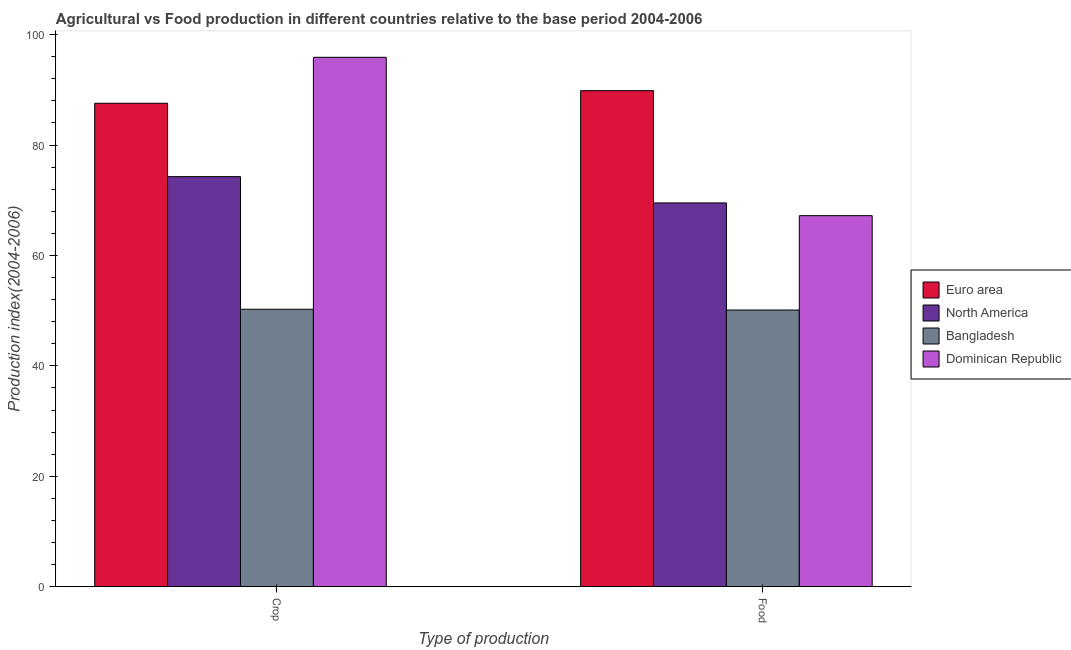How many different coloured bars are there?
Make the answer very short. 4. How many groups of bars are there?
Provide a short and direct response. 2. Are the number of bars per tick equal to the number of legend labels?
Give a very brief answer. Yes. What is the label of the 2nd group of bars from the left?
Offer a very short reply. Food. What is the crop production index in Bangladesh?
Offer a very short reply. 50.26. Across all countries, what is the maximum food production index?
Your response must be concise. 89.85. Across all countries, what is the minimum food production index?
Ensure brevity in your answer.  50.12. In which country was the crop production index maximum?
Provide a short and direct response. Dominican Republic. In which country was the food production index minimum?
Your answer should be very brief. Bangladesh. What is the total food production index in the graph?
Provide a succinct answer. 276.69. What is the difference between the food production index in Bangladesh and that in Dominican Republic?
Give a very brief answer. -17.09. What is the difference between the crop production index in Dominican Republic and the food production index in North America?
Your response must be concise. 26.37. What is the average crop production index per country?
Keep it short and to the point. 77. What is the difference between the food production index and crop production index in Bangladesh?
Offer a terse response. -0.14. What is the ratio of the crop production index in Dominican Republic to that in Euro area?
Provide a succinct answer. 1.1. What does the 1st bar from the right in Food represents?
Provide a short and direct response. Dominican Republic. How many bars are there?
Provide a succinct answer. 8. Are all the bars in the graph horizontal?
Ensure brevity in your answer.  No. What is the title of the graph?
Your answer should be very brief. Agricultural vs Food production in different countries relative to the base period 2004-2006. What is the label or title of the X-axis?
Your answer should be very brief. Type of production. What is the label or title of the Y-axis?
Offer a very short reply. Production index(2004-2006). What is the Production index(2004-2006) of Euro area in Crop?
Give a very brief answer. 87.57. What is the Production index(2004-2006) in North America in Crop?
Provide a succinct answer. 74.28. What is the Production index(2004-2006) in Bangladesh in Crop?
Your answer should be very brief. 50.26. What is the Production index(2004-2006) in Dominican Republic in Crop?
Your response must be concise. 95.89. What is the Production index(2004-2006) in Euro area in Food?
Give a very brief answer. 89.85. What is the Production index(2004-2006) of North America in Food?
Offer a very short reply. 69.52. What is the Production index(2004-2006) in Bangladesh in Food?
Your response must be concise. 50.12. What is the Production index(2004-2006) of Dominican Republic in Food?
Keep it short and to the point. 67.21. Across all Type of production, what is the maximum Production index(2004-2006) in Euro area?
Offer a very short reply. 89.85. Across all Type of production, what is the maximum Production index(2004-2006) of North America?
Offer a terse response. 74.28. Across all Type of production, what is the maximum Production index(2004-2006) in Bangladesh?
Your answer should be very brief. 50.26. Across all Type of production, what is the maximum Production index(2004-2006) of Dominican Republic?
Offer a very short reply. 95.89. Across all Type of production, what is the minimum Production index(2004-2006) in Euro area?
Keep it short and to the point. 87.57. Across all Type of production, what is the minimum Production index(2004-2006) of North America?
Offer a terse response. 69.52. Across all Type of production, what is the minimum Production index(2004-2006) in Bangladesh?
Make the answer very short. 50.12. Across all Type of production, what is the minimum Production index(2004-2006) in Dominican Republic?
Offer a terse response. 67.21. What is the total Production index(2004-2006) of Euro area in the graph?
Provide a short and direct response. 177.41. What is the total Production index(2004-2006) of North America in the graph?
Your answer should be compact. 143.8. What is the total Production index(2004-2006) of Bangladesh in the graph?
Keep it short and to the point. 100.38. What is the total Production index(2004-2006) of Dominican Republic in the graph?
Ensure brevity in your answer.  163.1. What is the difference between the Production index(2004-2006) in Euro area in Crop and that in Food?
Provide a succinct answer. -2.28. What is the difference between the Production index(2004-2006) in North America in Crop and that in Food?
Your answer should be very brief. 4.77. What is the difference between the Production index(2004-2006) of Bangladesh in Crop and that in Food?
Provide a succinct answer. 0.14. What is the difference between the Production index(2004-2006) of Dominican Republic in Crop and that in Food?
Your answer should be compact. 28.68. What is the difference between the Production index(2004-2006) of Euro area in Crop and the Production index(2004-2006) of North America in Food?
Your answer should be very brief. 18.05. What is the difference between the Production index(2004-2006) of Euro area in Crop and the Production index(2004-2006) of Bangladesh in Food?
Offer a very short reply. 37.45. What is the difference between the Production index(2004-2006) in Euro area in Crop and the Production index(2004-2006) in Dominican Republic in Food?
Your answer should be compact. 20.36. What is the difference between the Production index(2004-2006) of North America in Crop and the Production index(2004-2006) of Bangladesh in Food?
Ensure brevity in your answer.  24.16. What is the difference between the Production index(2004-2006) of North America in Crop and the Production index(2004-2006) of Dominican Republic in Food?
Your answer should be very brief. 7.07. What is the difference between the Production index(2004-2006) of Bangladesh in Crop and the Production index(2004-2006) of Dominican Republic in Food?
Your response must be concise. -16.95. What is the average Production index(2004-2006) of Euro area per Type of production?
Your answer should be compact. 88.71. What is the average Production index(2004-2006) of North America per Type of production?
Make the answer very short. 71.9. What is the average Production index(2004-2006) of Bangladesh per Type of production?
Keep it short and to the point. 50.19. What is the average Production index(2004-2006) of Dominican Republic per Type of production?
Ensure brevity in your answer.  81.55. What is the difference between the Production index(2004-2006) of Euro area and Production index(2004-2006) of North America in Crop?
Provide a short and direct response. 13.28. What is the difference between the Production index(2004-2006) in Euro area and Production index(2004-2006) in Bangladesh in Crop?
Give a very brief answer. 37.31. What is the difference between the Production index(2004-2006) of Euro area and Production index(2004-2006) of Dominican Republic in Crop?
Your answer should be compact. -8.32. What is the difference between the Production index(2004-2006) in North America and Production index(2004-2006) in Bangladesh in Crop?
Make the answer very short. 24.02. What is the difference between the Production index(2004-2006) in North America and Production index(2004-2006) in Dominican Republic in Crop?
Give a very brief answer. -21.61. What is the difference between the Production index(2004-2006) in Bangladesh and Production index(2004-2006) in Dominican Republic in Crop?
Make the answer very short. -45.63. What is the difference between the Production index(2004-2006) of Euro area and Production index(2004-2006) of North America in Food?
Provide a succinct answer. 20.33. What is the difference between the Production index(2004-2006) of Euro area and Production index(2004-2006) of Bangladesh in Food?
Your answer should be compact. 39.73. What is the difference between the Production index(2004-2006) in Euro area and Production index(2004-2006) in Dominican Republic in Food?
Offer a terse response. 22.64. What is the difference between the Production index(2004-2006) of North America and Production index(2004-2006) of Bangladesh in Food?
Ensure brevity in your answer.  19.4. What is the difference between the Production index(2004-2006) in North America and Production index(2004-2006) in Dominican Republic in Food?
Provide a short and direct response. 2.31. What is the difference between the Production index(2004-2006) in Bangladesh and Production index(2004-2006) in Dominican Republic in Food?
Your response must be concise. -17.09. What is the ratio of the Production index(2004-2006) of Euro area in Crop to that in Food?
Provide a succinct answer. 0.97. What is the ratio of the Production index(2004-2006) in North America in Crop to that in Food?
Give a very brief answer. 1.07. What is the ratio of the Production index(2004-2006) of Bangladesh in Crop to that in Food?
Ensure brevity in your answer.  1. What is the ratio of the Production index(2004-2006) in Dominican Republic in Crop to that in Food?
Give a very brief answer. 1.43. What is the difference between the highest and the second highest Production index(2004-2006) of Euro area?
Provide a succinct answer. 2.28. What is the difference between the highest and the second highest Production index(2004-2006) of North America?
Offer a terse response. 4.77. What is the difference between the highest and the second highest Production index(2004-2006) in Bangladesh?
Your answer should be very brief. 0.14. What is the difference between the highest and the second highest Production index(2004-2006) in Dominican Republic?
Ensure brevity in your answer.  28.68. What is the difference between the highest and the lowest Production index(2004-2006) of Euro area?
Provide a short and direct response. 2.28. What is the difference between the highest and the lowest Production index(2004-2006) in North America?
Your answer should be very brief. 4.77. What is the difference between the highest and the lowest Production index(2004-2006) of Bangladesh?
Your answer should be compact. 0.14. What is the difference between the highest and the lowest Production index(2004-2006) in Dominican Republic?
Your answer should be very brief. 28.68. 